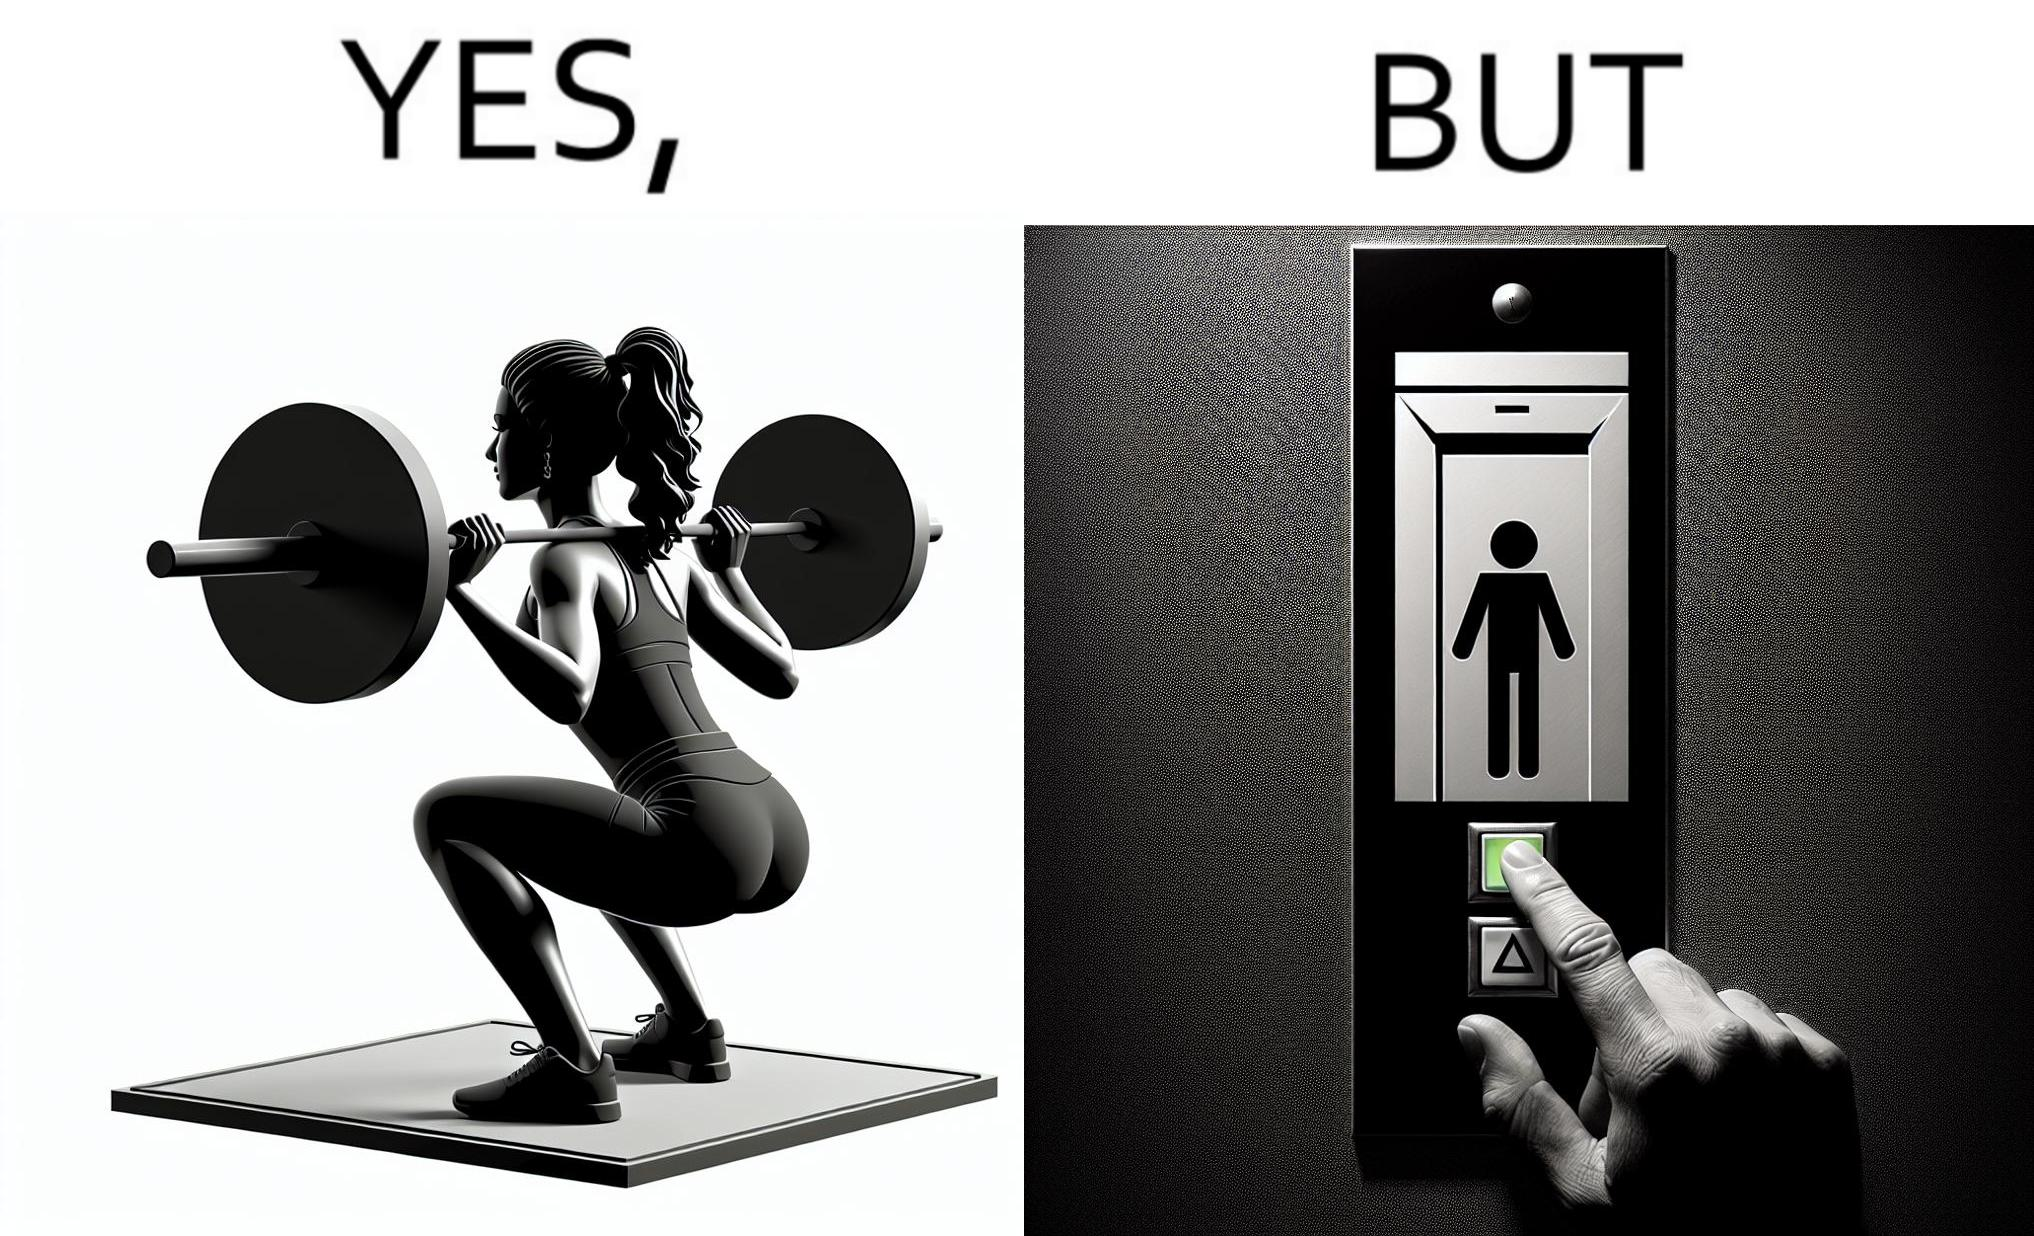Is this a satirical image? Yes, this image is satirical. 